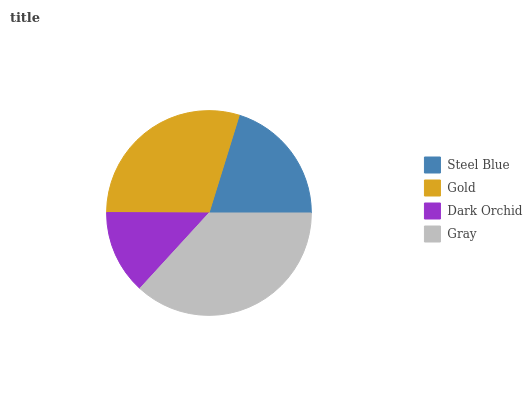Is Dark Orchid the minimum?
Answer yes or no. Yes. Is Gray the maximum?
Answer yes or no. Yes. Is Gold the minimum?
Answer yes or no. No. Is Gold the maximum?
Answer yes or no. No. Is Gold greater than Steel Blue?
Answer yes or no. Yes. Is Steel Blue less than Gold?
Answer yes or no. Yes. Is Steel Blue greater than Gold?
Answer yes or no. No. Is Gold less than Steel Blue?
Answer yes or no. No. Is Gold the high median?
Answer yes or no. Yes. Is Steel Blue the low median?
Answer yes or no. Yes. Is Dark Orchid the high median?
Answer yes or no. No. Is Gray the low median?
Answer yes or no. No. 